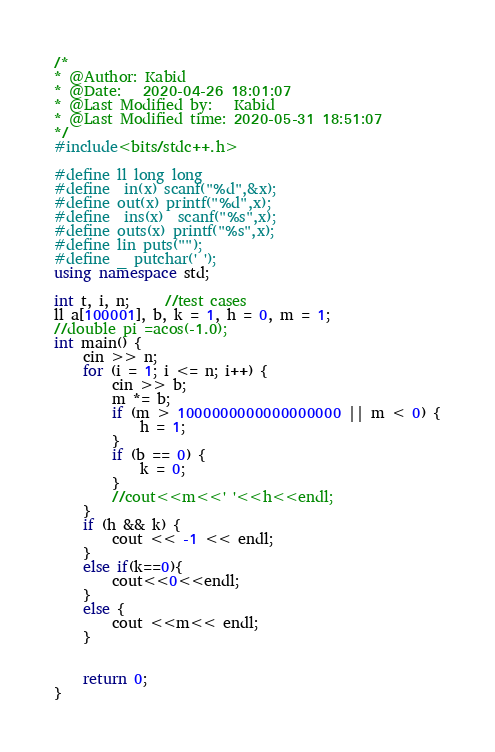Convert code to text. <code><loc_0><loc_0><loc_500><loc_500><_C++_>/*
* @Author: Kabid
* @Date:   2020-04-26 18:01:07
* @Last Modified by:   Kabid
* @Last Modified time: 2020-05-31 18:51:07
*/
#include<bits/stdc++.h>

#define ll long long
#define  in(x) scanf("%d",&x);
#define out(x) printf("%d",x);
#define  ins(x)  scanf("%s",x);
#define outs(x) printf("%s",x);
#define lin puts("");
#define _ putchar(' ');
using namespace std;

int t, i, n;     //test cases
ll a[100001], b, k = 1, h = 0, m = 1;
//double pi =acos(-1.0);
int main() {
	cin >> n;
	for (i = 1; i <= n; i++) {
		cin >> b;
		m *= b;
		if (m > 1000000000000000000 || m < 0) {
			h = 1;
		}
		if (b == 0) {
			k = 0;
		}
		//cout<<m<<' '<<h<<endl;
	}
	if (h && k) {
		cout << -1 << endl;
	}
	else if(k==0){
		cout<<0<<endl;
	}
	else {
		cout <<m<< endl;
	}


	return 0;
}


</code> 